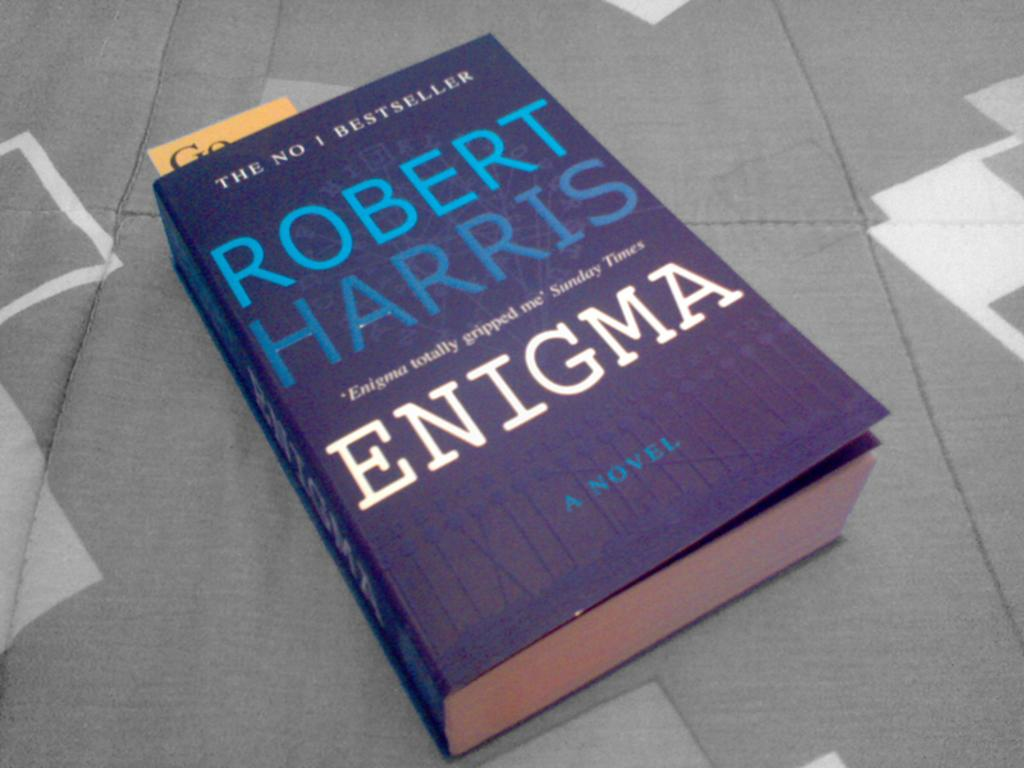Provide a one-sentence caption for the provided image. A copy of the book Enigma by Robert Harris. 